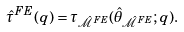Convert formula to latex. <formula><loc_0><loc_0><loc_500><loc_500>\hat { \tau } ^ { F E } ( q ) = \tau _ { \hat { \mathcal { M } } ^ { F E } } ( \hat { \theta } _ { \hat { \mathcal { M } } ^ { F E } } ; q ) .</formula> 